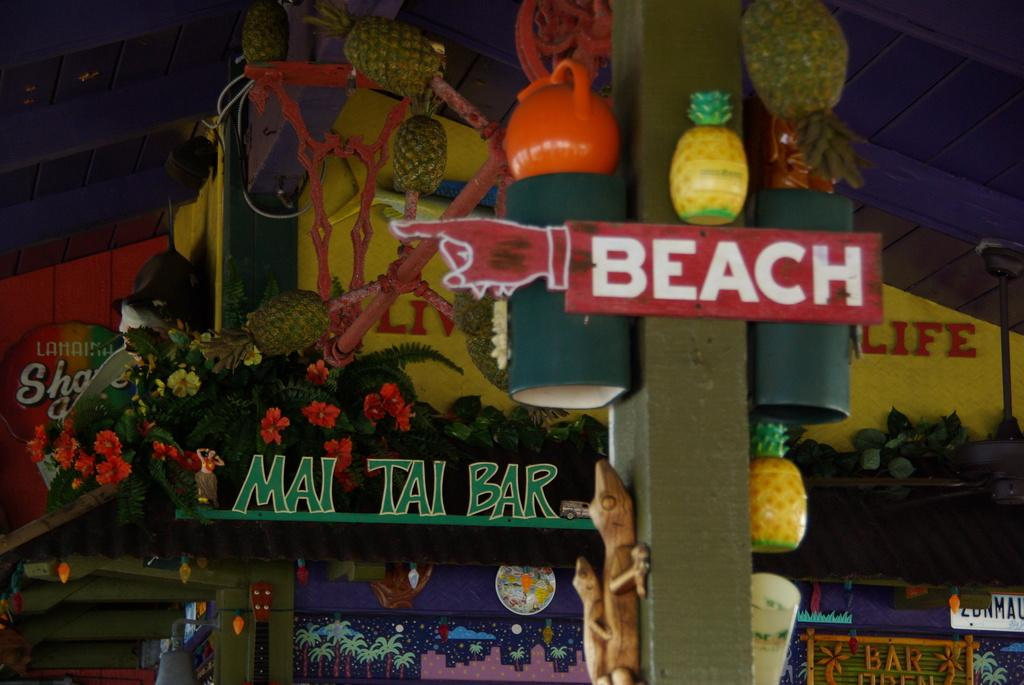Provide a one-sentence caption for the provided image. A Mai Tai bar storefront has a sign that is shaped like a pointing finger that directs people to the beach in front of it. 